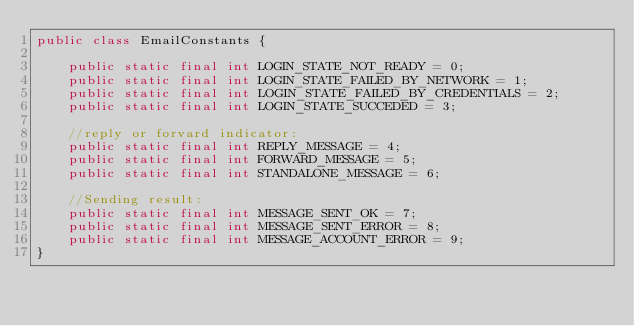Convert code to text. <code><loc_0><loc_0><loc_500><loc_500><_Java_>public class EmailConstants {
	
	public static final int LOGIN_STATE_NOT_READY = 0;
	public static final int LOGIN_STATE_FAILED_BY_NETWORK = 1;
	public static final int LOGIN_STATE_FAILED_BY_CREDENTIALS = 2;
	public static final int LOGIN_STATE_SUCCEDED = 3;
	
	//reply or forvard indicator:
	public static final int REPLY_MESSAGE = 4;
	public static final int FORWARD_MESSAGE = 5;
	public static final int STANDALONE_MESSAGE = 6;
	
	//Sending result:
	public static final int MESSAGE_SENT_OK = 7;
	public static final int MESSAGE_SENT_ERROR = 8;
	public static final int MESSAGE_ACCOUNT_ERROR = 9;
}
</code> 